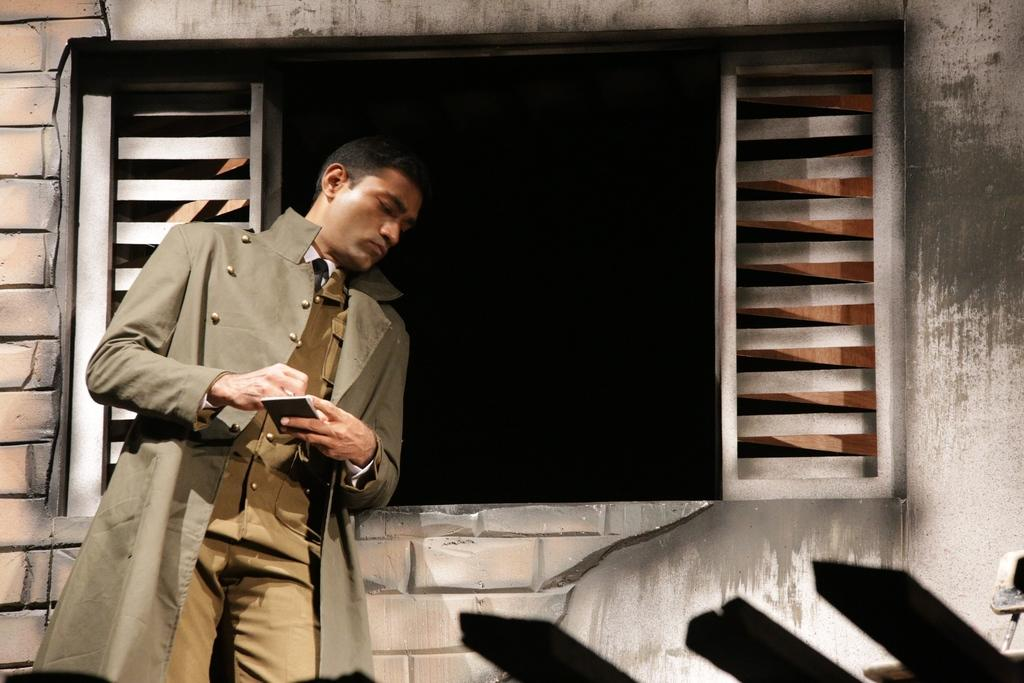What is the person doing in the image? The person is standing on the left side of the image. What is the person holding in the image? The person is holding an object in the image. What can be seen in the background of the image? There is a wall in the background of the image. What architectural feature is present in the middle of the image? There is a window in the middle of the image. What type of feather is the person using to knit with in the image? There is no feather or yarn present in the image, and the person is not knitting. 